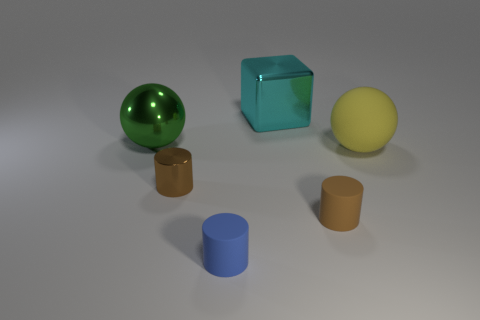What can you tell me about the lighting in this scene? The lighting in this scene appears to be coming from the upper left, casting soft shadows towards the lower right. This is evident from the shadows each object projects. The lighting contributes to the overall calm and serene mood of the scene and highlights the textures and materials of the objects. 